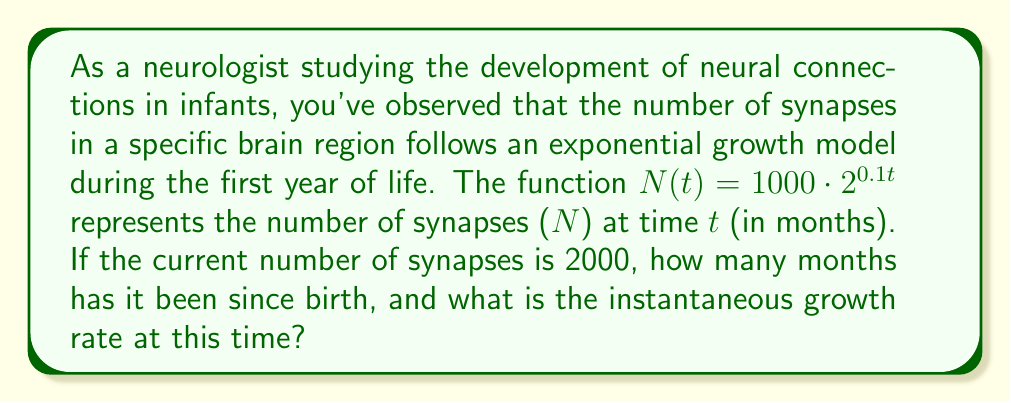Can you solve this math problem? To solve this problem, we'll use logarithms and derivatives. Let's break it down step-by-step:

1. Find the time (t) when N(t) = 2000:

   $$2000 = 1000 \cdot 2^{0.1t}$$
   
   Divide both sides by 1000:
   $$2 = 2^{0.1t}$$
   
   Take the logarithm (base 2) of both sides:
   $$\log_2(2) = \log_2(2^{0.1t})$$
   $$1 = 0.1t$$
   $$t = 10$$ months

2. Calculate the instantaneous growth rate:

   The instantaneous growth rate is given by the derivative of N(t) divided by N(t):
   
   $$\text{Growth Rate} = \frac{N'(t)}{N(t)}$$
   
   First, let's find N'(t):
   $$N'(t) = 1000 \cdot 2^{0.1t} \cdot 0.1 \cdot \ln(2)$$
   
   Now, calculate the growth rate:
   $$\text{Growth Rate} = \frac{1000 \cdot 2^{0.1t} \cdot 0.1 \cdot \ln(2)}{1000 \cdot 2^{0.1t}}$$
   
   Simplify:
   $$\text{Growth Rate} = 0.1 \cdot \ln(2) \approx 0.0693$$ or about 6.93% per month

This growth rate is constant for this exponential model, regardless of the time t.
Answer: The number of synapses reached 2000 after 10 months, and the instantaneous growth rate at this time (and at all times) is approximately 6.93% per month. 